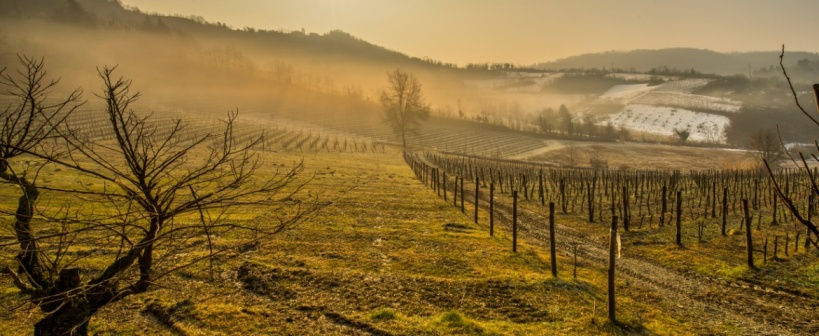Could this vineyard be used for purposes other than wine production? What might those be? Absolutely, vineyards can serve multiple purposes beyond wine production. For instance, they can be used for educational tours, providing insight into the art and science of viticulture. They could also host events, like weddings or corporate gatherings, taking advantage of the picturesque landscape. Additionally, vineyards like this can participate in research activities, focusing on sustainable farming practices or biodiversity studies, making them centers for learning and conservation. 